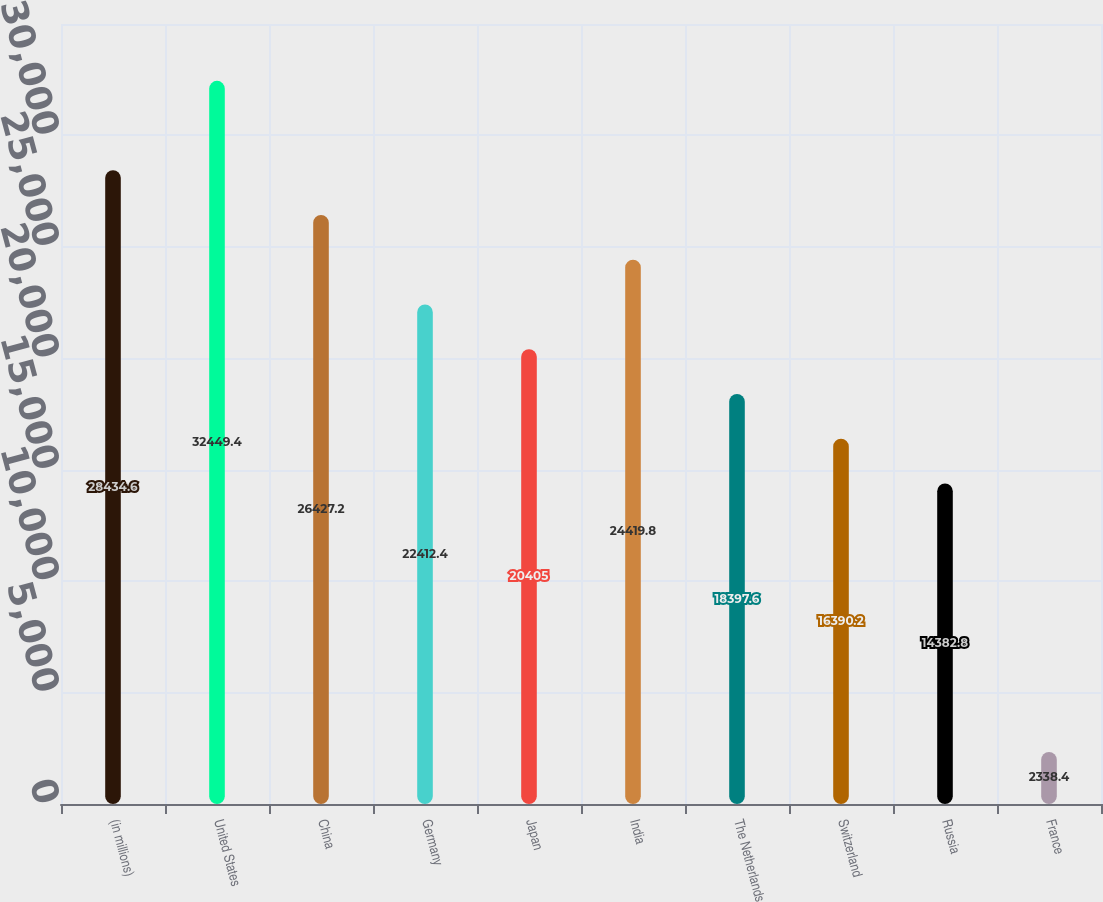Convert chart to OTSL. <chart><loc_0><loc_0><loc_500><loc_500><bar_chart><fcel>(in millions)<fcel>United States<fcel>China<fcel>Germany<fcel>Japan<fcel>India<fcel>The Netherlands<fcel>Switzerland<fcel>Russia<fcel>France<nl><fcel>28434.6<fcel>32449.4<fcel>26427.2<fcel>22412.4<fcel>20405<fcel>24419.8<fcel>18397.6<fcel>16390.2<fcel>14382.8<fcel>2338.4<nl></chart> 